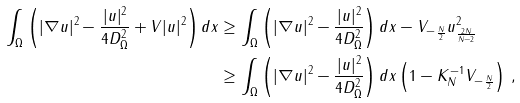<formula> <loc_0><loc_0><loc_500><loc_500>\int _ { \Omega } \left ( | \nabla u | ^ { 2 } - \frac { | u | ^ { 2 } } { 4 D _ { \Omega } ^ { 2 } } + V | u | ^ { 2 } \right ) d x & \geq \int _ { \Omega } \left ( | \nabla u | ^ { 2 } - \frac { | u | ^ { 2 } } { 4 D _ { \Omega } ^ { 2 } } \right ) d x - \| V _ { - } \| _ { \frac { N } { 2 } } \| u \| _ { \frac { 2 N } { N - 2 } } ^ { 2 } \\ & \geq \int _ { \Omega } \left ( | \nabla u | ^ { 2 } - \frac { | u | ^ { 2 } } { 4 D _ { \Omega } ^ { 2 } } \right ) d x \left ( 1 - K _ { N } ^ { - 1 } \| V _ { - } \| _ { \frac { N } { 2 } } \right ) \, ,</formula> 